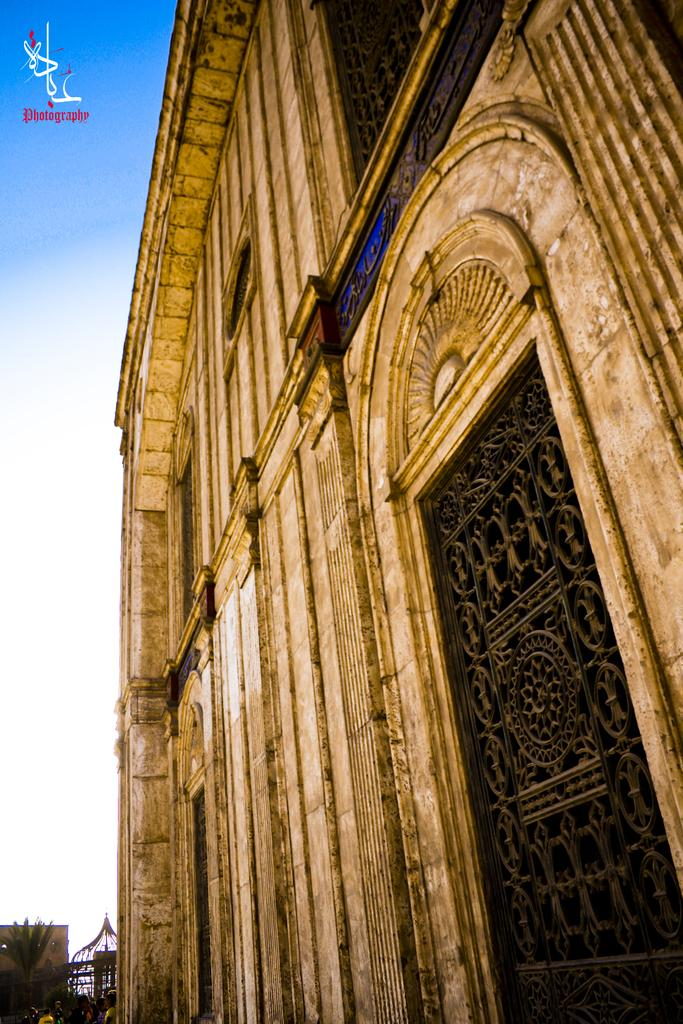What type of building is in the image? There is a cathedral in the image. Are there any people in the image? Yes, there are people in the image. What can be seen in the background of the image? There is a tree visible in the background of the image. What type of smell can be detected coming from the secretary in the image? There is no secretary present in the image, so it is not possible to determine what type of smell might be detected. 